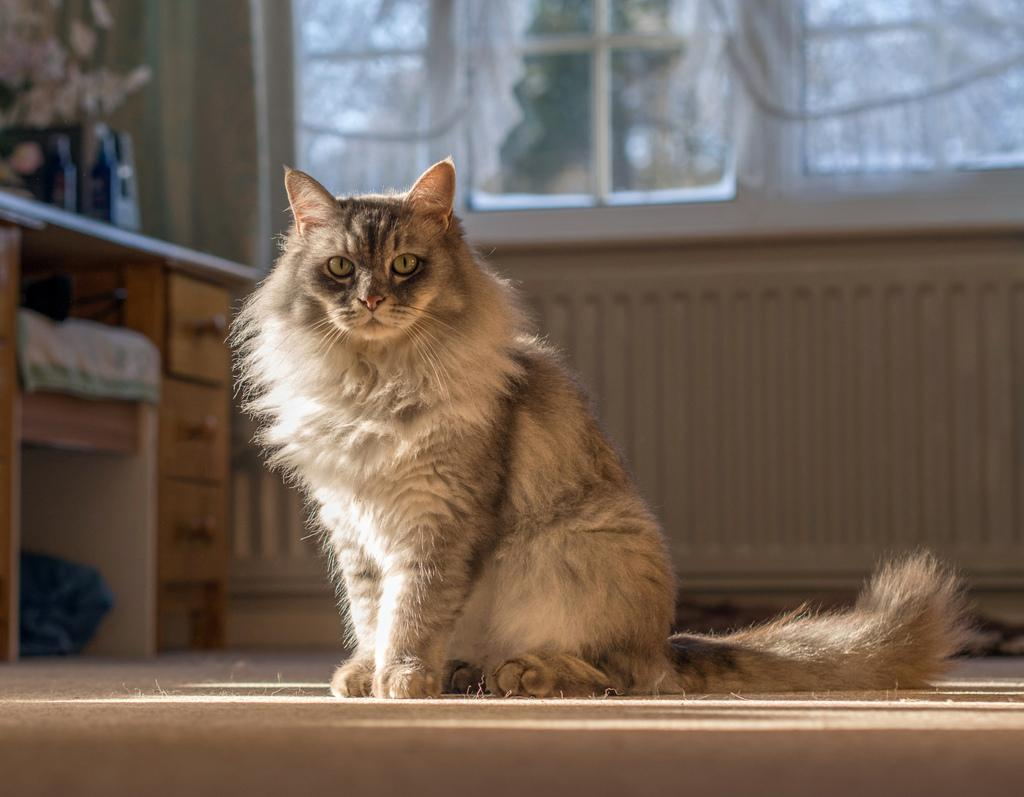What is the main subject in the center of the image? There is a cat sitting in the center of the image. What can be seen in the background of the image? There is a window in the background of the image. What is located on the left side of the image? There is a table on the left side of the image. What is placed on the table? There are things placed on the table. What type of apple is being used to promote peace in the image? There is no apple or reference to peace promotion in the image; it features a cat sitting in the center. 